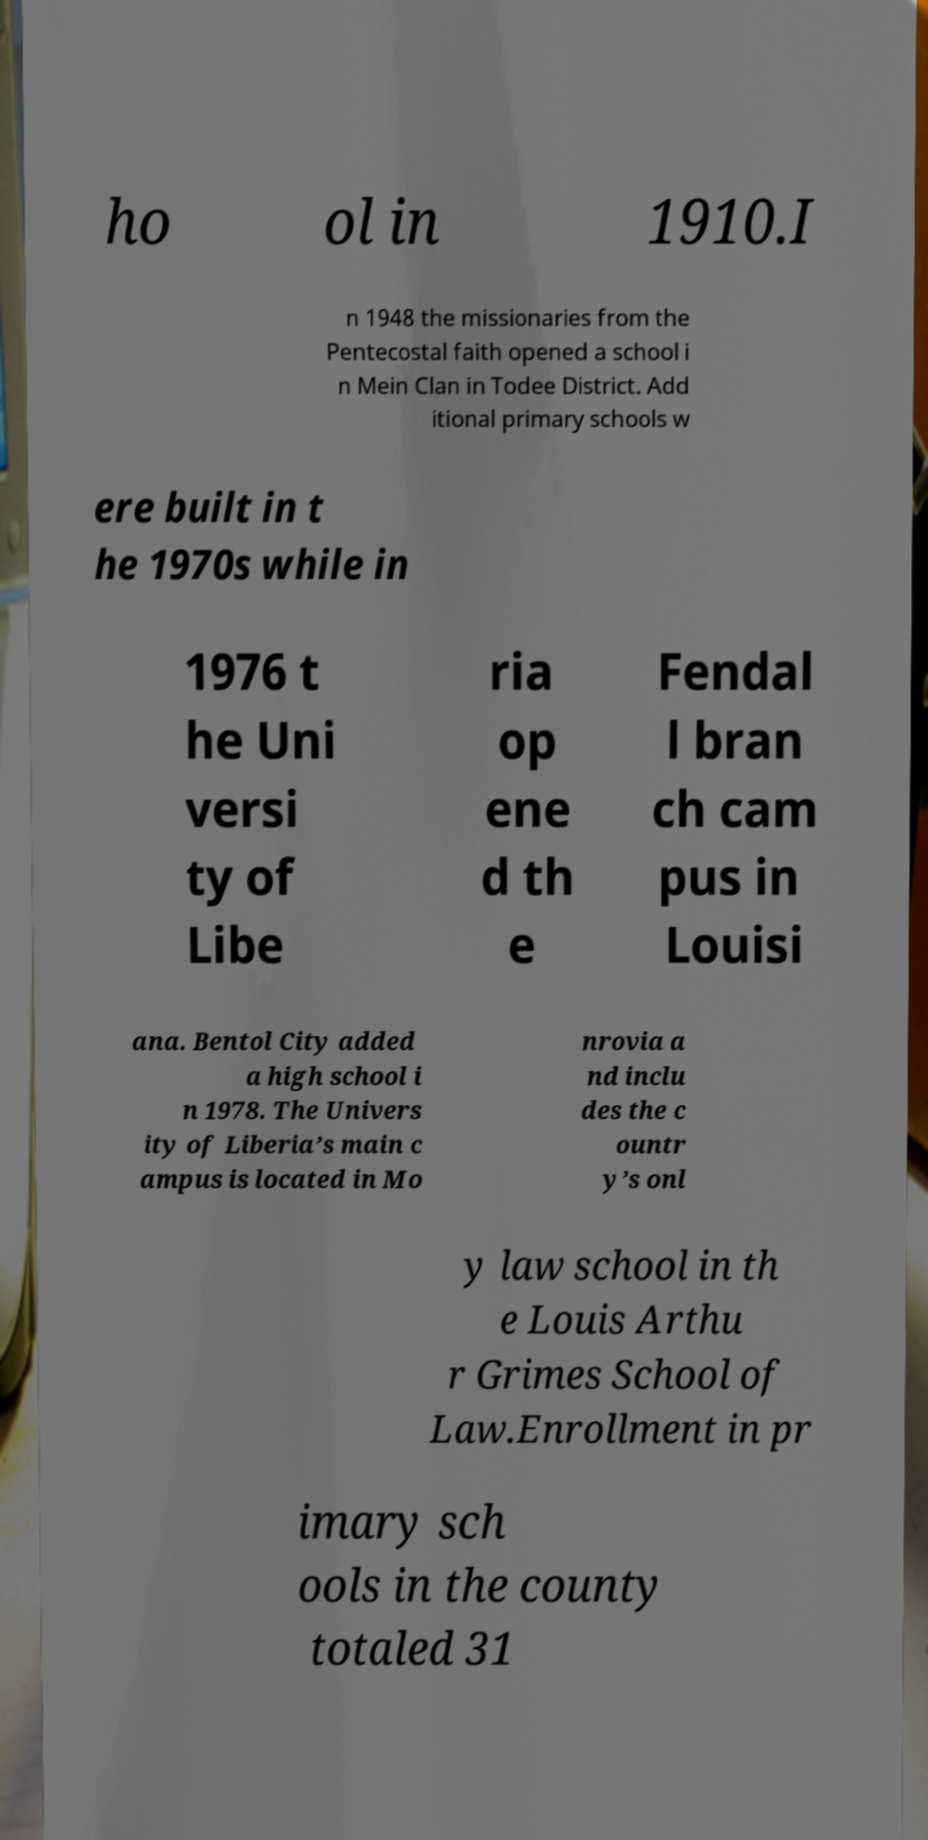Could you extract and type out the text from this image? ho ol in 1910.I n 1948 the missionaries from the Pentecostal faith opened a school i n Mein Clan in Todee District. Add itional primary schools w ere built in t he 1970s while in 1976 t he Uni versi ty of Libe ria op ene d th e Fendal l bran ch cam pus in Louisi ana. Bentol City added a high school i n 1978. The Univers ity of Liberia’s main c ampus is located in Mo nrovia a nd inclu des the c ountr y’s onl y law school in th e Louis Arthu r Grimes School of Law.Enrollment in pr imary sch ools in the county totaled 31 